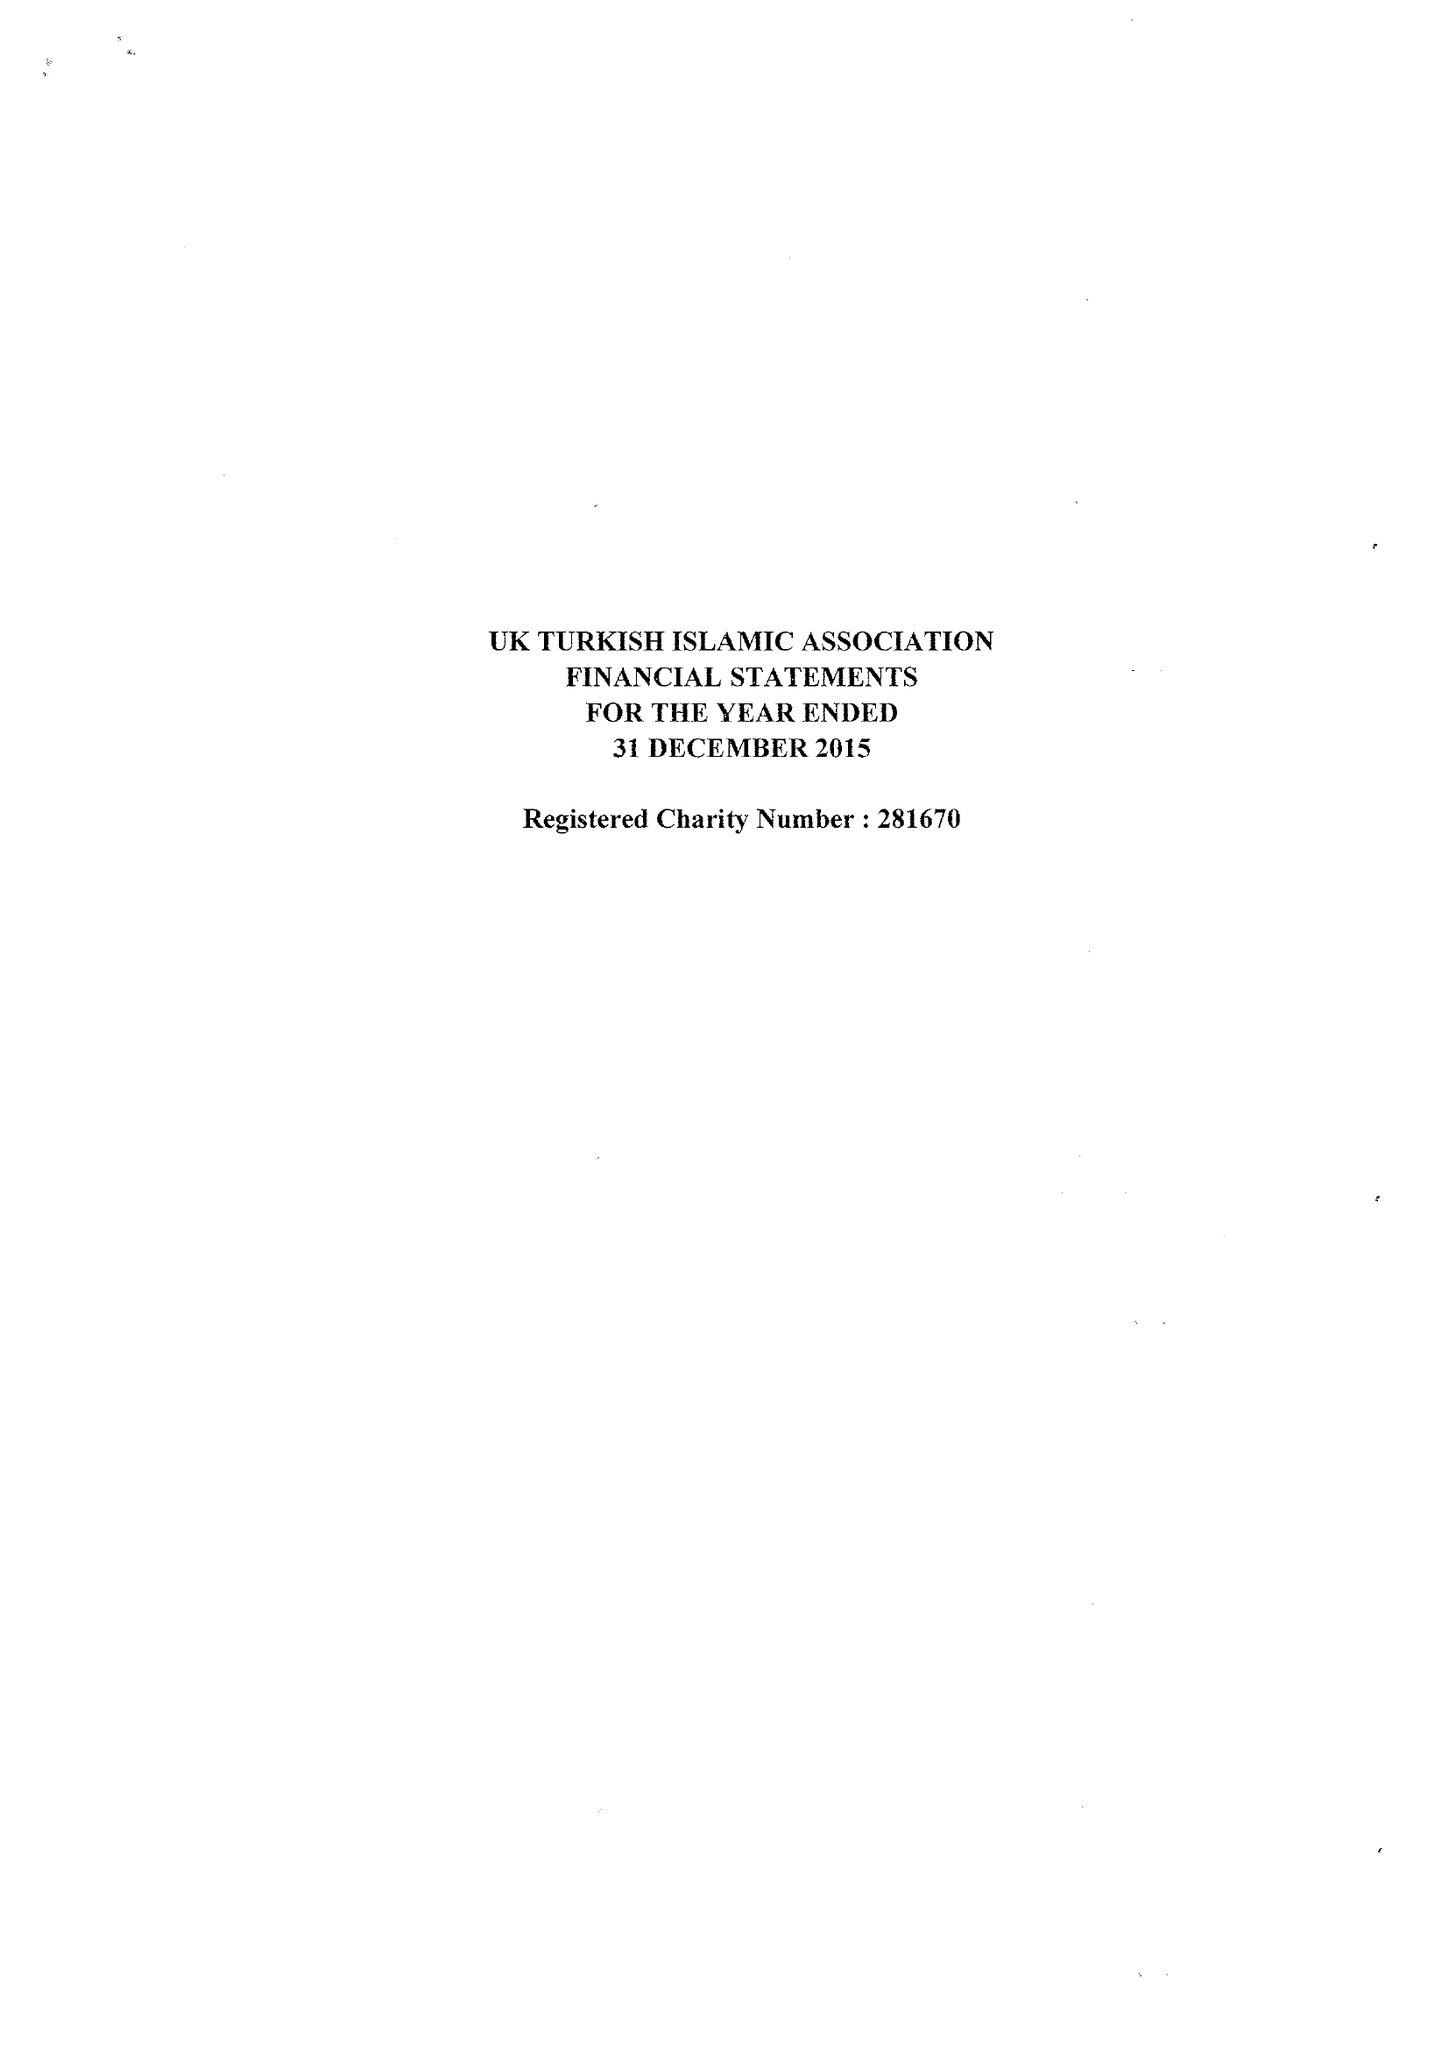What is the value for the charity_number?
Answer the question using a single word or phrase. 281670 